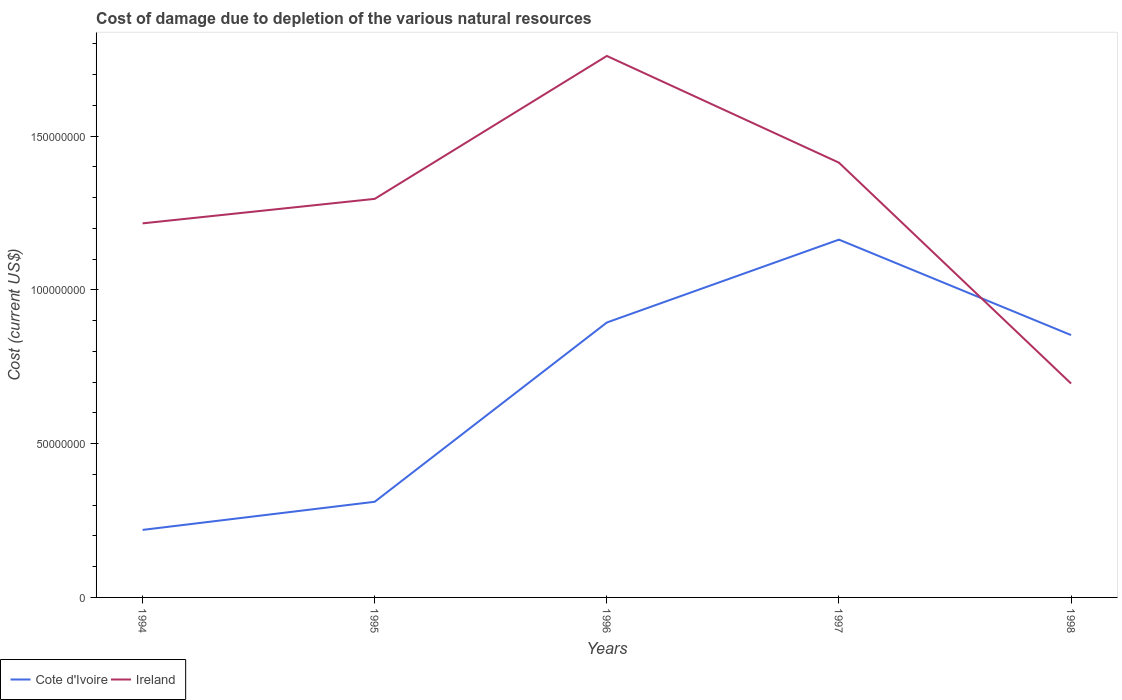How many different coloured lines are there?
Your response must be concise. 2. Across all years, what is the maximum cost of damage caused due to the depletion of various natural resources in Ireland?
Your response must be concise. 6.95e+07. What is the total cost of damage caused due to the depletion of various natural resources in Ireland in the graph?
Make the answer very short. 6.00e+07. What is the difference between the highest and the second highest cost of damage caused due to the depletion of various natural resources in Cote d'Ivoire?
Ensure brevity in your answer.  9.44e+07. What is the difference between the highest and the lowest cost of damage caused due to the depletion of various natural resources in Cote d'Ivoire?
Offer a very short reply. 3. Is the cost of damage caused due to the depletion of various natural resources in Ireland strictly greater than the cost of damage caused due to the depletion of various natural resources in Cote d'Ivoire over the years?
Provide a succinct answer. No. How many lines are there?
Offer a very short reply. 2. Are the values on the major ticks of Y-axis written in scientific E-notation?
Provide a short and direct response. No. Does the graph contain grids?
Your answer should be very brief. No. Where does the legend appear in the graph?
Make the answer very short. Bottom left. How many legend labels are there?
Offer a terse response. 2. What is the title of the graph?
Offer a very short reply. Cost of damage due to depletion of the various natural resources. What is the label or title of the X-axis?
Provide a short and direct response. Years. What is the label or title of the Y-axis?
Provide a succinct answer. Cost (current US$). What is the Cost (current US$) of Cote d'Ivoire in 1994?
Offer a terse response. 2.20e+07. What is the Cost (current US$) of Ireland in 1994?
Offer a terse response. 1.22e+08. What is the Cost (current US$) of Cote d'Ivoire in 1995?
Your answer should be very brief. 3.11e+07. What is the Cost (current US$) in Ireland in 1995?
Your answer should be compact. 1.30e+08. What is the Cost (current US$) of Cote d'Ivoire in 1996?
Keep it short and to the point. 8.94e+07. What is the Cost (current US$) of Ireland in 1996?
Ensure brevity in your answer.  1.76e+08. What is the Cost (current US$) of Cote d'Ivoire in 1997?
Provide a succinct answer. 1.16e+08. What is the Cost (current US$) of Ireland in 1997?
Provide a short and direct response. 1.41e+08. What is the Cost (current US$) of Cote d'Ivoire in 1998?
Make the answer very short. 8.53e+07. What is the Cost (current US$) in Ireland in 1998?
Your answer should be compact. 6.95e+07. Across all years, what is the maximum Cost (current US$) of Cote d'Ivoire?
Make the answer very short. 1.16e+08. Across all years, what is the maximum Cost (current US$) in Ireland?
Your answer should be compact. 1.76e+08. Across all years, what is the minimum Cost (current US$) in Cote d'Ivoire?
Give a very brief answer. 2.20e+07. Across all years, what is the minimum Cost (current US$) of Ireland?
Provide a succinct answer. 6.95e+07. What is the total Cost (current US$) in Cote d'Ivoire in the graph?
Ensure brevity in your answer.  3.44e+08. What is the total Cost (current US$) in Ireland in the graph?
Provide a succinct answer. 6.38e+08. What is the difference between the Cost (current US$) in Cote d'Ivoire in 1994 and that in 1995?
Keep it short and to the point. -9.14e+06. What is the difference between the Cost (current US$) of Ireland in 1994 and that in 1995?
Provide a short and direct response. -7.96e+06. What is the difference between the Cost (current US$) in Cote d'Ivoire in 1994 and that in 1996?
Ensure brevity in your answer.  -6.74e+07. What is the difference between the Cost (current US$) of Ireland in 1994 and that in 1996?
Ensure brevity in your answer.  -5.44e+07. What is the difference between the Cost (current US$) of Cote d'Ivoire in 1994 and that in 1997?
Provide a short and direct response. -9.44e+07. What is the difference between the Cost (current US$) of Ireland in 1994 and that in 1997?
Provide a succinct answer. -1.97e+07. What is the difference between the Cost (current US$) in Cote d'Ivoire in 1994 and that in 1998?
Offer a very short reply. -6.33e+07. What is the difference between the Cost (current US$) of Ireland in 1994 and that in 1998?
Offer a very short reply. 5.21e+07. What is the difference between the Cost (current US$) in Cote d'Ivoire in 1995 and that in 1996?
Ensure brevity in your answer.  -5.83e+07. What is the difference between the Cost (current US$) of Ireland in 1995 and that in 1996?
Offer a very short reply. -4.65e+07. What is the difference between the Cost (current US$) of Cote d'Ivoire in 1995 and that in 1997?
Offer a terse response. -8.52e+07. What is the difference between the Cost (current US$) in Ireland in 1995 and that in 1997?
Give a very brief answer. -1.18e+07. What is the difference between the Cost (current US$) in Cote d'Ivoire in 1995 and that in 1998?
Your answer should be compact. -5.42e+07. What is the difference between the Cost (current US$) of Ireland in 1995 and that in 1998?
Your answer should be compact. 6.00e+07. What is the difference between the Cost (current US$) of Cote d'Ivoire in 1996 and that in 1997?
Ensure brevity in your answer.  -2.69e+07. What is the difference between the Cost (current US$) in Ireland in 1996 and that in 1997?
Ensure brevity in your answer.  3.47e+07. What is the difference between the Cost (current US$) in Cote d'Ivoire in 1996 and that in 1998?
Offer a terse response. 4.09e+06. What is the difference between the Cost (current US$) in Ireland in 1996 and that in 1998?
Your response must be concise. 1.07e+08. What is the difference between the Cost (current US$) of Cote d'Ivoire in 1997 and that in 1998?
Your response must be concise. 3.10e+07. What is the difference between the Cost (current US$) in Ireland in 1997 and that in 1998?
Your response must be concise. 7.18e+07. What is the difference between the Cost (current US$) of Cote d'Ivoire in 1994 and the Cost (current US$) of Ireland in 1995?
Your answer should be compact. -1.08e+08. What is the difference between the Cost (current US$) of Cote d'Ivoire in 1994 and the Cost (current US$) of Ireland in 1996?
Make the answer very short. -1.54e+08. What is the difference between the Cost (current US$) in Cote d'Ivoire in 1994 and the Cost (current US$) in Ireland in 1997?
Make the answer very short. -1.19e+08. What is the difference between the Cost (current US$) in Cote d'Ivoire in 1994 and the Cost (current US$) in Ireland in 1998?
Ensure brevity in your answer.  -4.76e+07. What is the difference between the Cost (current US$) in Cote d'Ivoire in 1995 and the Cost (current US$) in Ireland in 1996?
Ensure brevity in your answer.  -1.45e+08. What is the difference between the Cost (current US$) in Cote d'Ivoire in 1995 and the Cost (current US$) in Ireland in 1997?
Your answer should be very brief. -1.10e+08. What is the difference between the Cost (current US$) in Cote d'Ivoire in 1995 and the Cost (current US$) in Ireland in 1998?
Your answer should be compact. -3.84e+07. What is the difference between the Cost (current US$) in Cote d'Ivoire in 1996 and the Cost (current US$) in Ireland in 1997?
Make the answer very short. -5.20e+07. What is the difference between the Cost (current US$) in Cote d'Ivoire in 1996 and the Cost (current US$) in Ireland in 1998?
Give a very brief answer. 1.98e+07. What is the difference between the Cost (current US$) in Cote d'Ivoire in 1997 and the Cost (current US$) in Ireland in 1998?
Offer a terse response. 4.68e+07. What is the average Cost (current US$) in Cote d'Ivoire per year?
Offer a very short reply. 6.88e+07. What is the average Cost (current US$) of Ireland per year?
Your answer should be compact. 1.28e+08. In the year 1994, what is the difference between the Cost (current US$) of Cote d'Ivoire and Cost (current US$) of Ireland?
Your response must be concise. -9.97e+07. In the year 1995, what is the difference between the Cost (current US$) in Cote d'Ivoire and Cost (current US$) in Ireland?
Offer a terse response. -9.85e+07. In the year 1996, what is the difference between the Cost (current US$) of Cote d'Ivoire and Cost (current US$) of Ireland?
Keep it short and to the point. -8.67e+07. In the year 1997, what is the difference between the Cost (current US$) of Cote d'Ivoire and Cost (current US$) of Ireland?
Ensure brevity in your answer.  -2.50e+07. In the year 1998, what is the difference between the Cost (current US$) of Cote d'Ivoire and Cost (current US$) of Ireland?
Your response must be concise. 1.58e+07. What is the ratio of the Cost (current US$) of Cote d'Ivoire in 1994 to that in 1995?
Give a very brief answer. 0.71. What is the ratio of the Cost (current US$) in Ireland in 1994 to that in 1995?
Offer a terse response. 0.94. What is the ratio of the Cost (current US$) in Cote d'Ivoire in 1994 to that in 1996?
Ensure brevity in your answer.  0.25. What is the ratio of the Cost (current US$) in Ireland in 1994 to that in 1996?
Your answer should be compact. 0.69. What is the ratio of the Cost (current US$) of Cote d'Ivoire in 1994 to that in 1997?
Offer a terse response. 0.19. What is the ratio of the Cost (current US$) in Ireland in 1994 to that in 1997?
Keep it short and to the point. 0.86. What is the ratio of the Cost (current US$) in Cote d'Ivoire in 1994 to that in 1998?
Offer a very short reply. 0.26. What is the ratio of the Cost (current US$) in Ireland in 1994 to that in 1998?
Give a very brief answer. 1.75. What is the ratio of the Cost (current US$) of Cote d'Ivoire in 1995 to that in 1996?
Provide a succinct answer. 0.35. What is the ratio of the Cost (current US$) of Ireland in 1995 to that in 1996?
Offer a terse response. 0.74. What is the ratio of the Cost (current US$) in Cote d'Ivoire in 1995 to that in 1997?
Ensure brevity in your answer.  0.27. What is the ratio of the Cost (current US$) in Ireland in 1995 to that in 1997?
Provide a succinct answer. 0.92. What is the ratio of the Cost (current US$) in Cote d'Ivoire in 1995 to that in 1998?
Your answer should be very brief. 0.36. What is the ratio of the Cost (current US$) in Ireland in 1995 to that in 1998?
Your answer should be compact. 1.86. What is the ratio of the Cost (current US$) in Cote d'Ivoire in 1996 to that in 1997?
Give a very brief answer. 0.77. What is the ratio of the Cost (current US$) in Ireland in 1996 to that in 1997?
Your response must be concise. 1.25. What is the ratio of the Cost (current US$) of Cote d'Ivoire in 1996 to that in 1998?
Your answer should be very brief. 1.05. What is the ratio of the Cost (current US$) of Ireland in 1996 to that in 1998?
Your answer should be compact. 2.53. What is the ratio of the Cost (current US$) of Cote d'Ivoire in 1997 to that in 1998?
Offer a very short reply. 1.36. What is the ratio of the Cost (current US$) of Ireland in 1997 to that in 1998?
Your answer should be compact. 2.03. What is the difference between the highest and the second highest Cost (current US$) in Cote d'Ivoire?
Offer a very short reply. 2.69e+07. What is the difference between the highest and the second highest Cost (current US$) of Ireland?
Your answer should be compact. 3.47e+07. What is the difference between the highest and the lowest Cost (current US$) in Cote d'Ivoire?
Offer a very short reply. 9.44e+07. What is the difference between the highest and the lowest Cost (current US$) in Ireland?
Give a very brief answer. 1.07e+08. 